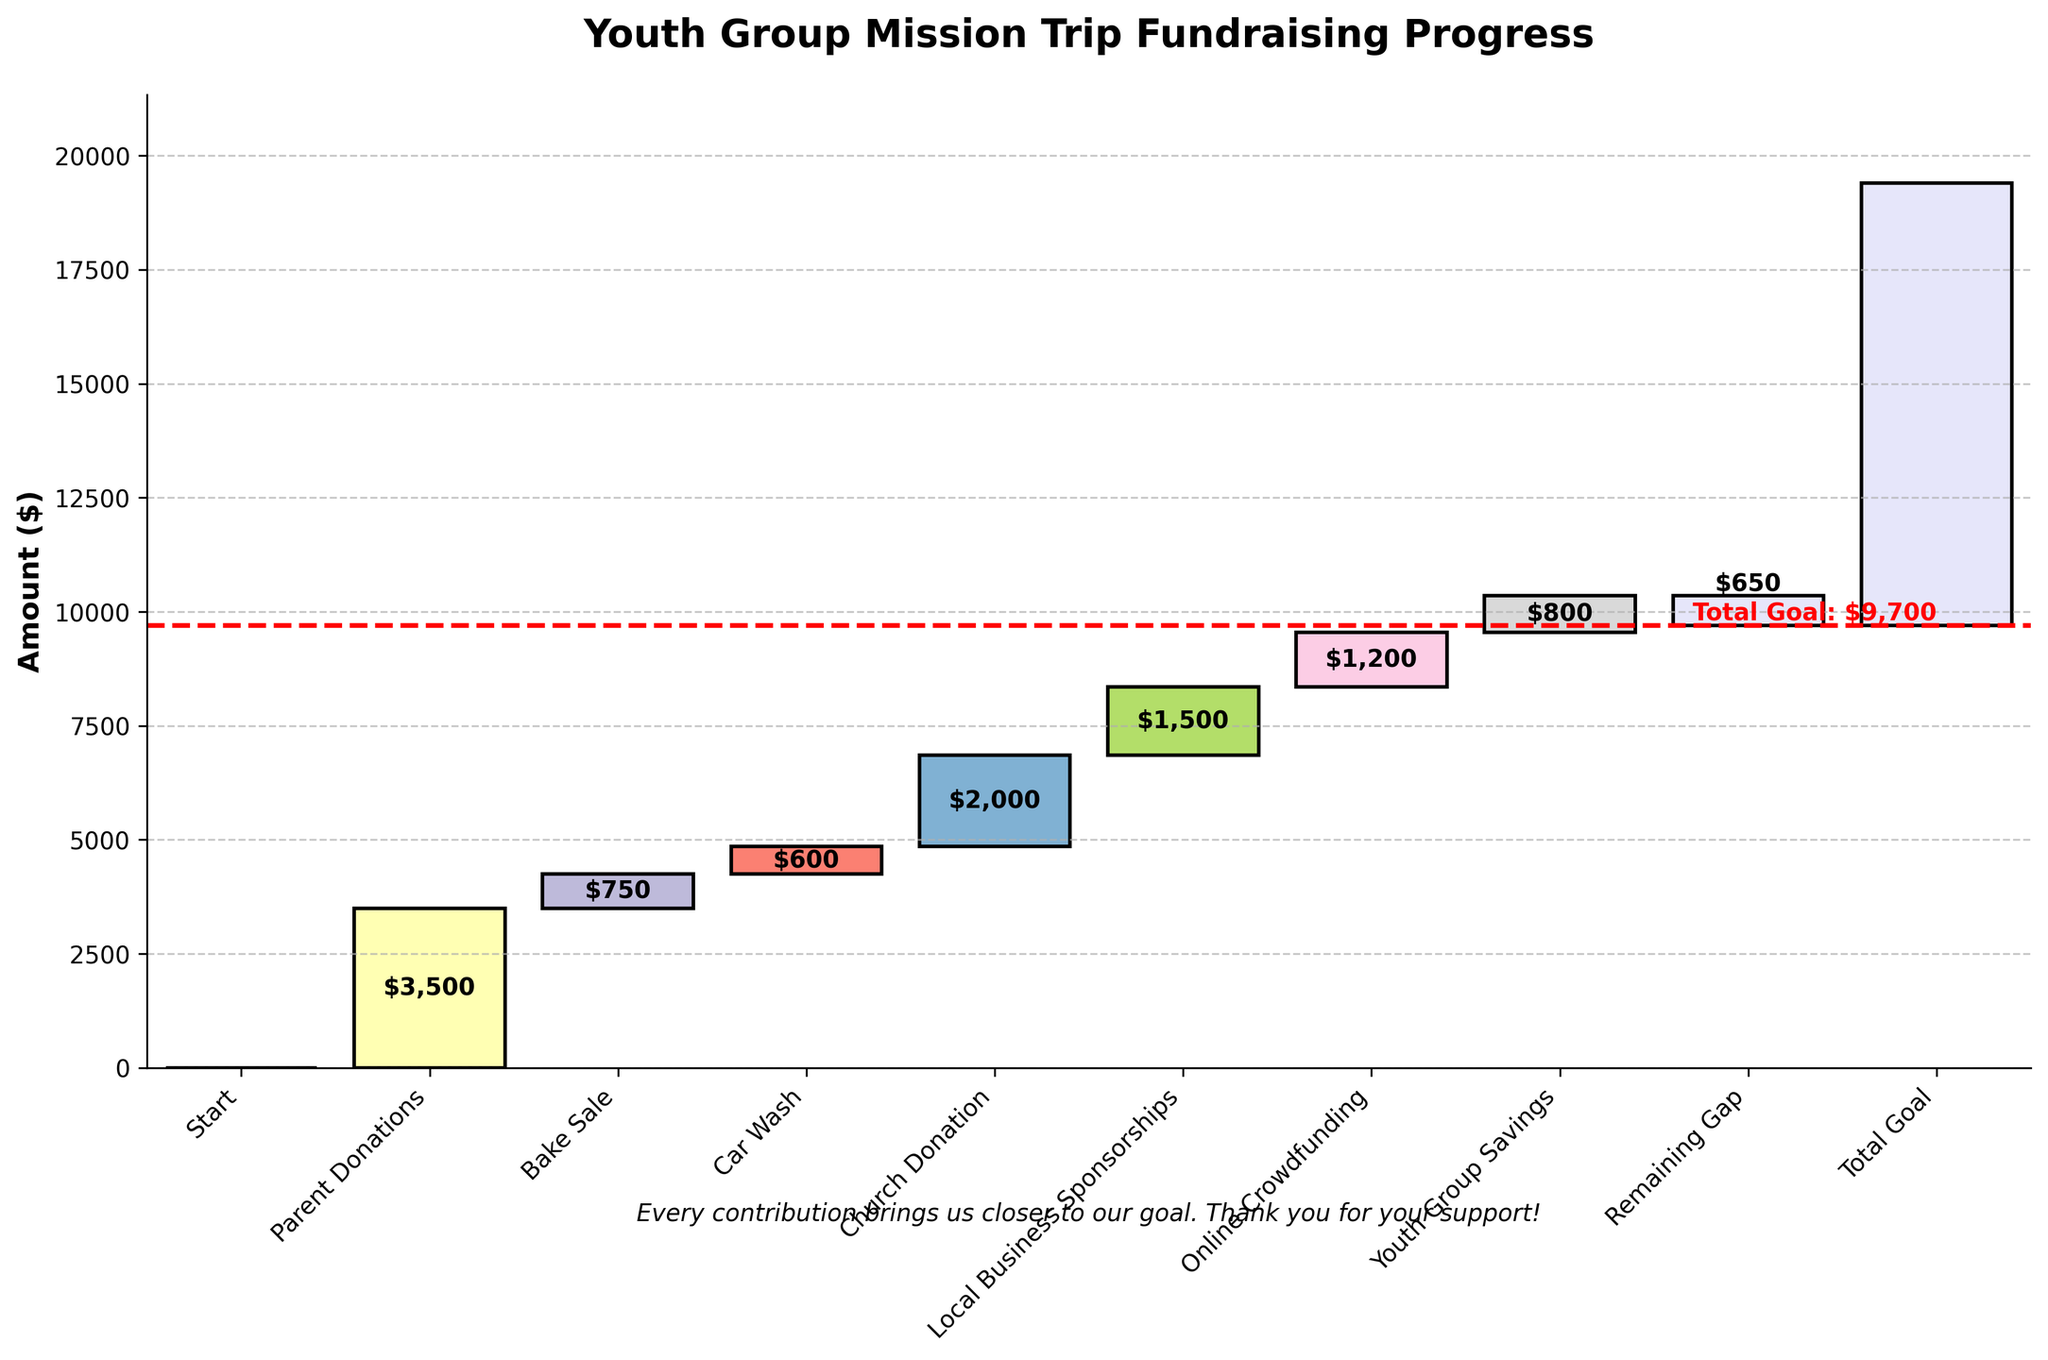What's the total amount raised from Parent Donations? The Parent Donations bar represents $3,500 as indicated by the label on the bar corresponding to it.
Answer: $3,500 What's the title of the chart? The title of the chart is displayed prominently at the top and reads "Youth Group Mission Trip Fundraising Progress."
Answer: Youth Group Mission Trip Fundraising Progress How much more is needed to reach the total goal? The "Remaining Gap" bar shows -$650, indicating the shortfall to reach the $9,700 total goal.
Answer: $650 Which fundraising source brought in the least amount of money? By comparing the heights and labels of all the bars, the Car Wash brought in the least at $600.
Answer: Car Wash What is the combined amount raised from Bake Sale and Online Crowdfunding? Add the amounts for Bake Sale ($750) and Online Crowdfunding ($1,200): $750 + $1,200 = $1,950.
Answer: $1,950 How does the Church Donation compare to the Local Business Sponsorships? The height and the label of the Church Donation bar indicate $2,000, while Local Business Sponsorships are $1,500. $2,000 > $1,500.
Answer: Church Donation is $500 more than Local Business Sponsorships Which category is color-coded in light lavender? The light lavender color is used for the "Start", "Total Goal", and "Remaining Gap" bars as noted in the chart's visual appearance.
Answer: Start, Total Goal, Remaining Gap How much money in total was raised excluding the Youth Group Savings? Exclude the Youth Group Savings ($800); sum the other contributions: $3,500 + $750 + $600 + $2,000 + $1,500 + $1,200 = $9,550.
Answer: $9,550 Where is the annotation about gratitude located in the chart? The annotation "Every contribution brings us closer to our goal. Thank you for your support!" is located below the x-axis in the chart.
Answer: Below the x-axis What is the cumulative total of funds raised up to and including the Youth Group Savings? Sum the amounts up to and including Youth Group Savings: $3,500 + $750 + $600 + $2,000 + $1,500 + $1,200 + $800 = $10,350.
Answer: $10,350 